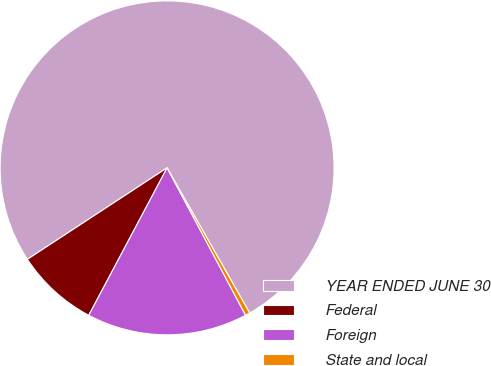Convert chart to OTSL. <chart><loc_0><loc_0><loc_500><loc_500><pie_chart><fcel>YEAR ENDED JUNE 30<fcel>Federal<fcel>Foreign<fcel>State and local<nl><fcel>75.99%<fcel>8.0%<fcel>15.56%<fcel>0.45%<nl></chart> 